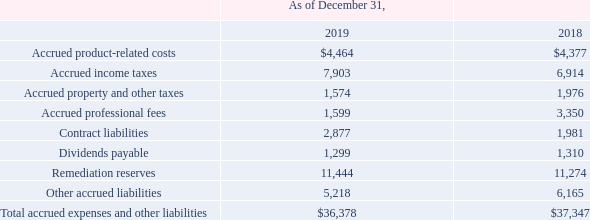NOTES TO CONSOLIDATED FINANCIAL STATEMENTS (in thousands, except for share and per share data)
NOTE 9 — Accrued Expenses and Other Liabilities
The components of accrued expenses and other liabilities are as follows:
Which years does the table provide information for the components of accrued expenses and other liabilities? 2019, 2018. What were the Remediation reserves in 2019?
Answer scale should be: thousand. 11,444. What was the Total accrued expenses and other liabilities in 2018?
Answer scale should be: thousand. 37,347. Which years did Dividends payable exceed $1,000 thousand? (2019:1,299),(2018:1,310)
Answer: 2019, 2018. What was the change in contract liabilities between 2018 and 2019?
Answer scale should be: thousand. 2,877-1,981
Answer: 896. What was the percentage change in the Other accrued liabilities between 2018 and 2019?
Answer scale should be: percent. (5,218-6,165)/6,165
Answer: -15.36. 